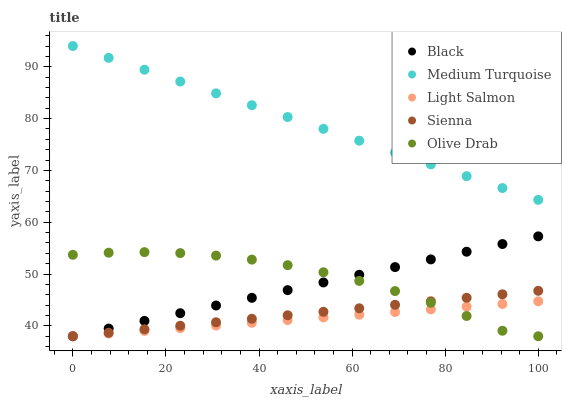Does Light Salmon have the minimum area under the curve?
Answer yes or no. Yes. Does Medium Turquoise have the maximum area under the curve?
Answer yes or no. Yes. Does Black have the minimum area under the curve?
Answer yes or no. No. Does Black have the maximum area under the curve?
Answer yes or no. No. Is Black the smoothest?
Answer yes or no. Yes. Is Olive Drab the roughest?
Answer yes or no. Yes. Is Light Salmon the smoothest?
Answer yes or no. No. Is Light Salmon the roughest?
Answer yes or no. No. Does Sienna have the lowest value?
Answer yes or no. Yes. Does Medium Turquoise have the lowest value?
Answer yes or no. No. Does Medium Turquoise have the highest value?
Answer yes or no. Yes. Does Black have the highest value?
Answer yes or no. No. Is Light Salmon less than Medium Turquoise?
Answer yes or no. Yes. Is Medium Turquoise greater than Olive Drab?
Answer yes or no. Yes. Does Light Salmon intersect Sienna?
Answer yes or no. Yes. Is Light Salmon less than Sienna?
Answer yes or no. No. Is Light Salmon greater than Sienna?
Answer yes or no. No. Does Light Salmon intersect Medium Turquoise?
Answer yes or no. No. 